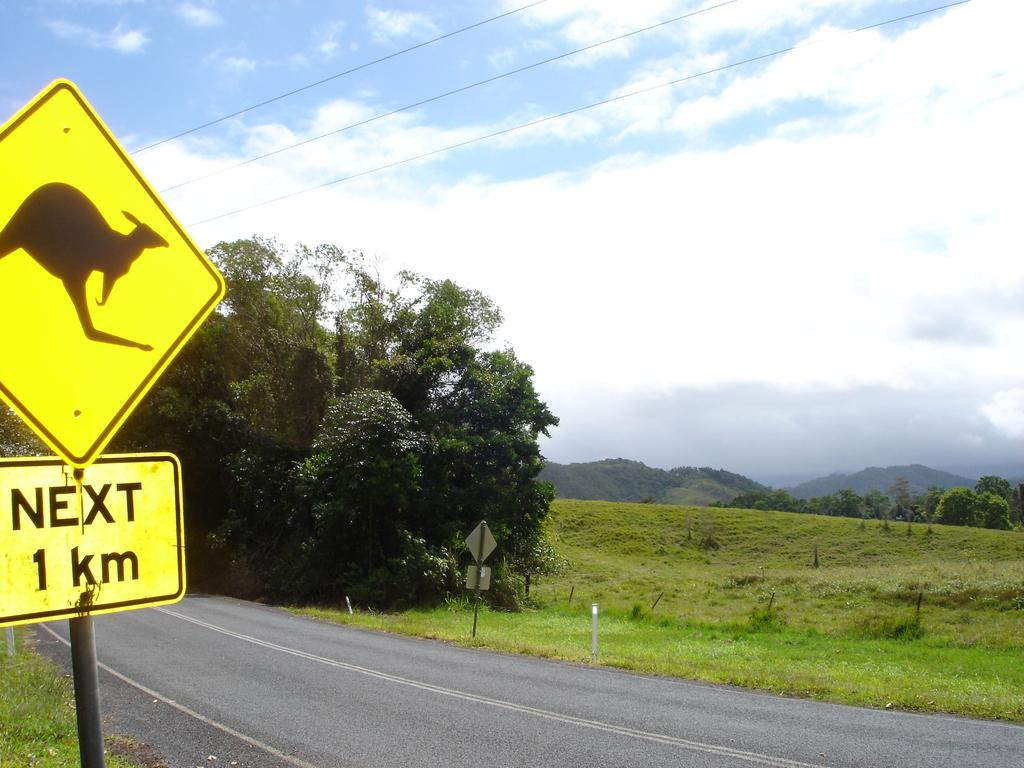<image>
Summarize the visual content of the image. A yellow yield sign in front of a grassy field that says Next 1 Km. 